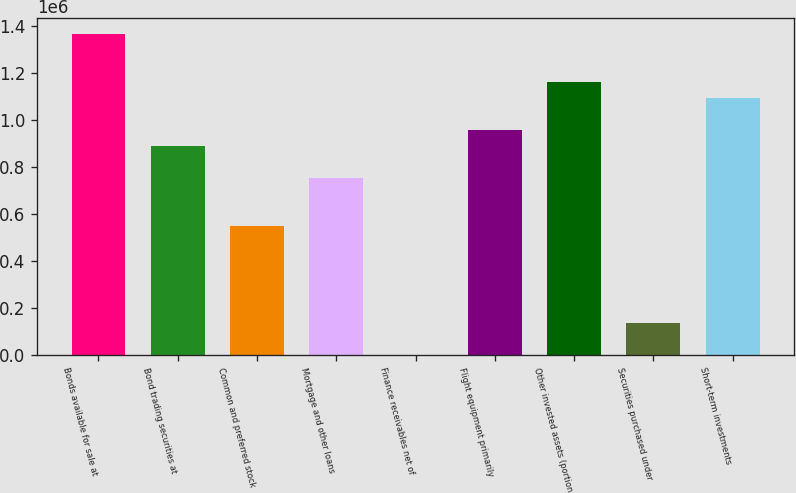Convert chart to OTSL. <chart><loc_0><loc_0><loc_500><loc_500><bar_chart><fcel>Bonds available for sale at<fcel>Bond trading securities at<fcel>Common and preferred stock<fcel>Mortgage and other loans<fcel>Finance receivables net of<fcel>Flight equipment primarily<fcel>Other invested assets (portion<fcel>Securities purchased under<fcel>Short-term investments<nl><fcel>1.36602e+06<fcel>888215<fcel>546928<fcel>751700<fcel>870<fcel>956472<fcel>1.16124e+06<fcel>137385<fcel>1.09299e+06<nl></chart> 